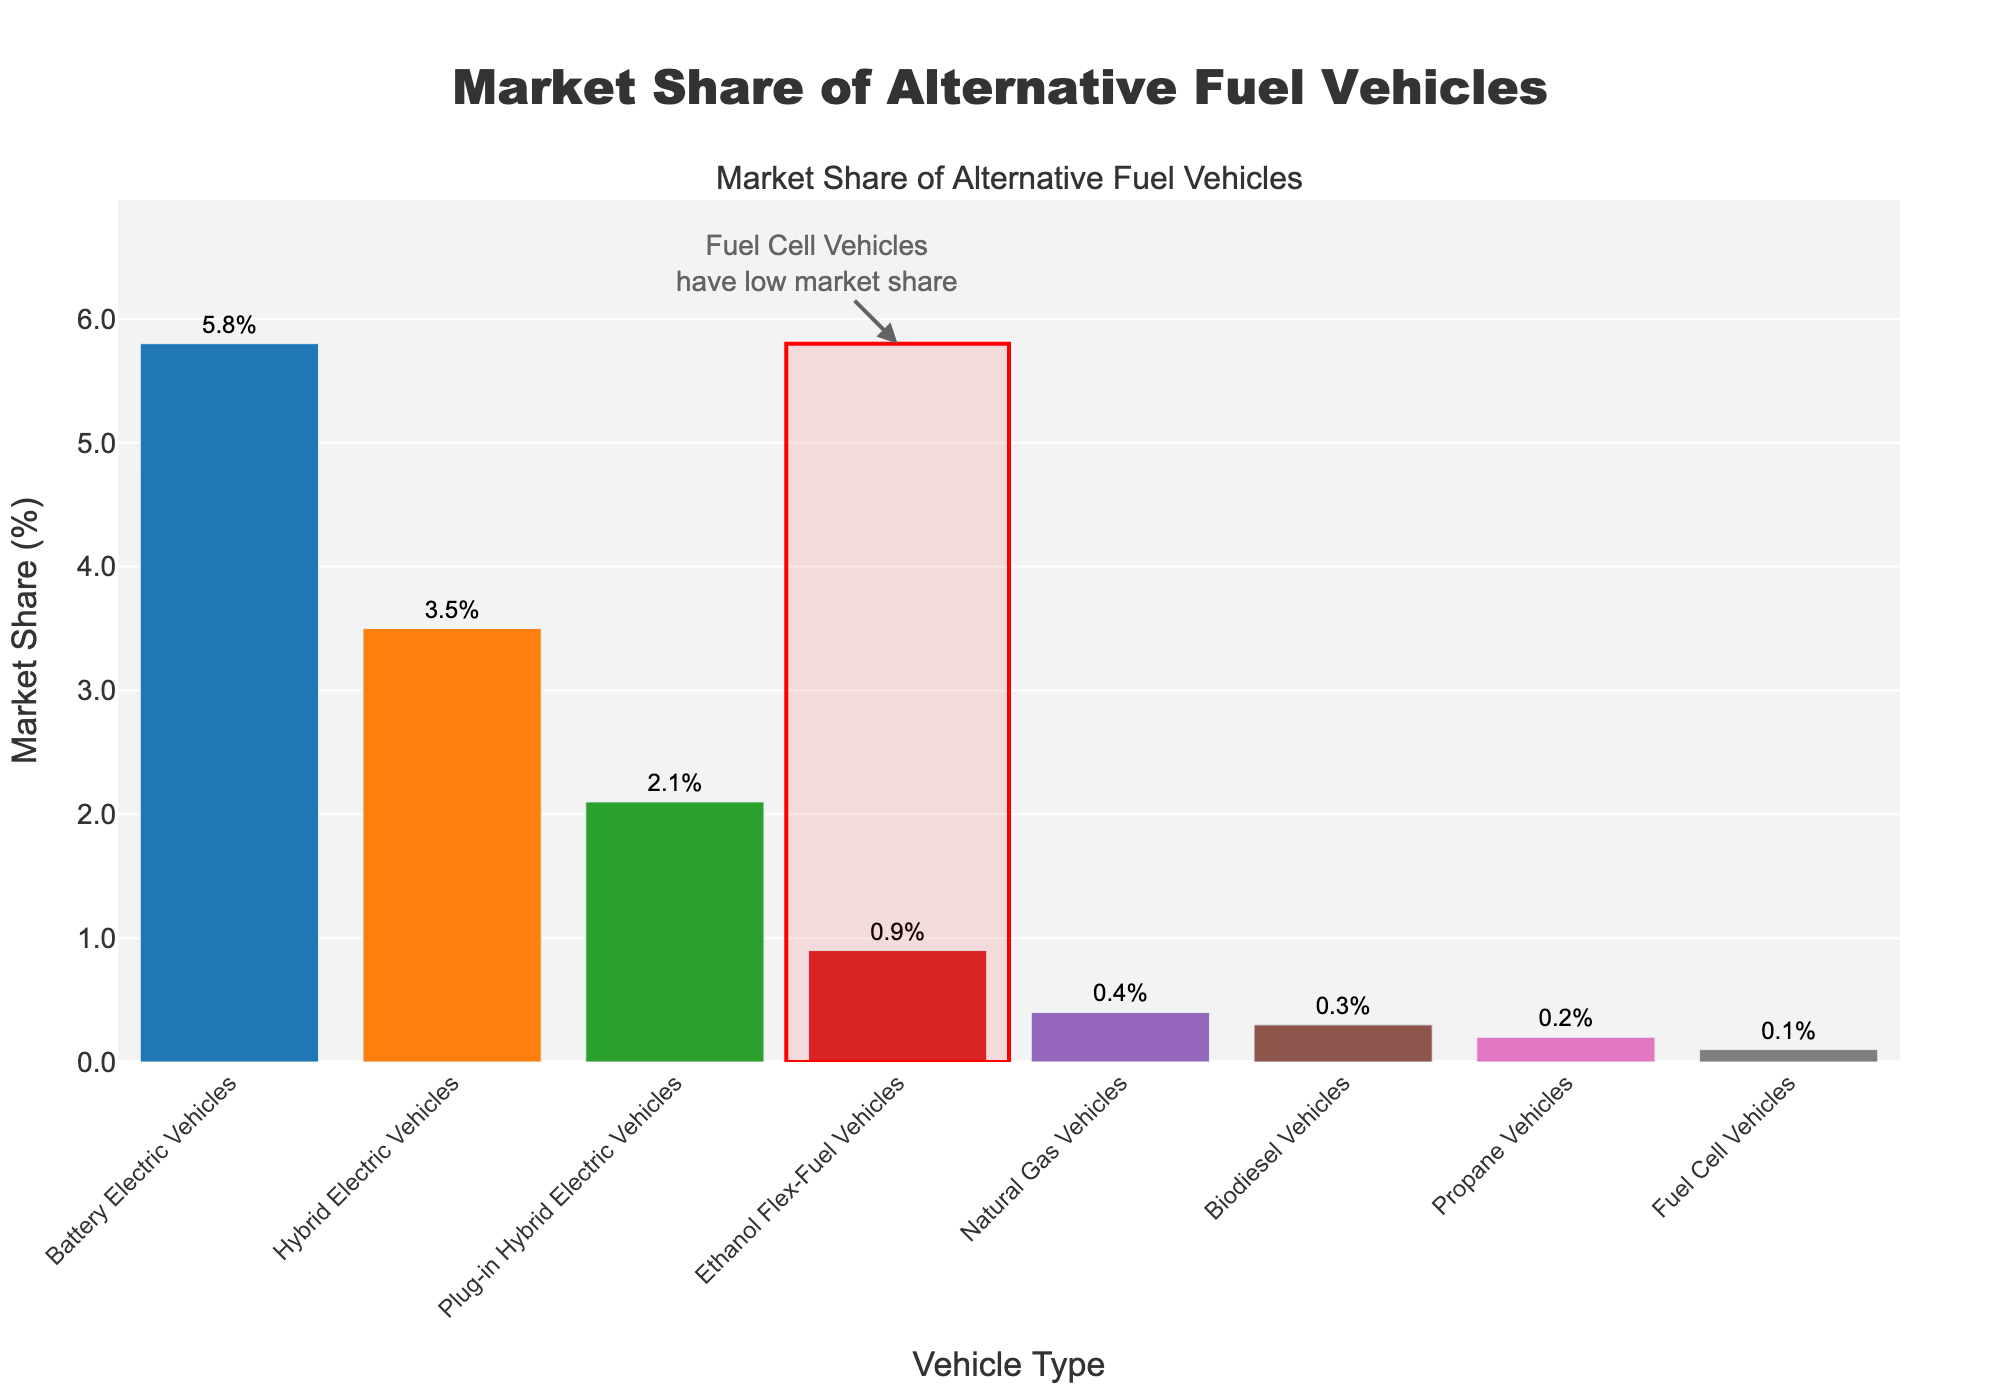Which vehicle type has the largest market share? By looking at the height of the bars in the chart, the Battery Electric Vehicles bar is the tallest, indicating it has the largest market share.
Answer: Battery Electric Vehicles How does the market share of Fuel Cell Vehicles compare to Ethanol Flex-Fuel Vehicles? By comparing the height of the bars, the Ethanol Flex-Fuel Vehicles bar is taller than the Fuel Cell Vehicles bar.
Answer: Fuel Cell Vehicles have a smaller market share What is the combined market share of Plug-in Hybrid Electric Vehicles, Natural Gas Vehicles, and Propane Vehicles? The market shares are: Plug-in Hybrid Electric Vehicles (2.1%), Natural Gas Vehicles (0.4%), and Propane Vehicles (0.2%). Adding these values: 2.1 + 0.4 + 0.2 = 2.7%.
Answer: 2.7% Which vehicle type has the closest market share to Hybrid Electric Vehicles? By visually checking the bars' height, Ethanol Flex-Fuel Vehicles with a market share of 0.9% is closest to Hybrid Electric Vehicles with 3.5%.
Answer: No vehicle type is close to Hybrid Electric Vehicles What is the average market share of all vehicle types listed in the chart? Sum the market shares: 5.8 + 2.1 + 0.1 + 3.5 + 0.4 + 0.9 + 0.2 + 0.3 = 13.3%. Divide by the number of vehicle types which is 8: 13.3 / 8 = 1.6625%.
Answer: 1.7% How much higher is the market share of Battery Electric Vehicles compared to Biodiesel Vehicles? The market share of Battery Electric Vehicles is 5.8%, and Biodiesel Vehicles is 0.3%. The difference is 5.8 - 0.3 = 5.5%.
Answer: 5.5% Which vehicle types have a market share less than 1%? By looking at the height of the bars and their corresponding values, the vehicle types with market share less than 1% are: Fuel Cell Vehicles (0.1%), Natural Gas Vehicles (0.4%), Ethanol Flex-Fuel Vehicles (0.9%), Propane Vehicles (0.2%), and Biodiesel Vehicles (0.3%).
Answer: Fuel Cell Vehicles, Natural Gas Vehicles, Propane Vehicles, Biodiesel Vehicles What fraction of the total combined market share do Fuel Cell Vehicles hold? The total market share is 13.3%. Fuel Cell Vehicles have a market share of 0.1%. Thus, the fraction is 0.1 / 13.3 = roughly 0.0075.
Answer: ~0.0075 Identify the vehicles with market shares represented by bars that are longer than Fuel Cell Vehicles but shorter than Hybrid Electric Vehicles. The taller bar than Fuel Cell Vehicles (0.1%) but shorter than Hybrid Electric Vehicles (3.5%) are Ethanol Flex-Fuel Vehicles (0.9%), Natural Gas Vehicles (0.4%), and Propane Vehicles (0.2%).
Answer: Ethanol Flex-Fuel Vehicles, Natural Gas Vehicles, Propane Vehicles 